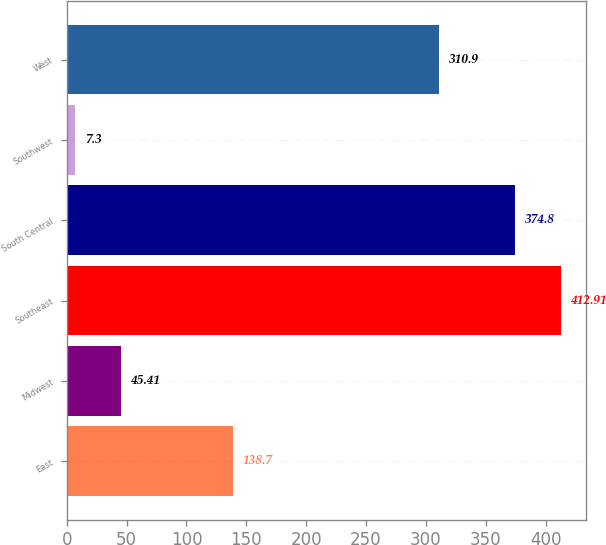Convert chart. <chart><loc_0><loc_0><loc_500><loc_500><bar_chart><fcel>East<fcel>Midwest<fcel>Southeast<fcel>South Central<fcel>Southwest<fcel>West<nl><fcel>138.7<fcel>45.41<fcel>412.91<fcel>374.8<fcel>7.3<fcel>310.9<nl></chart> 